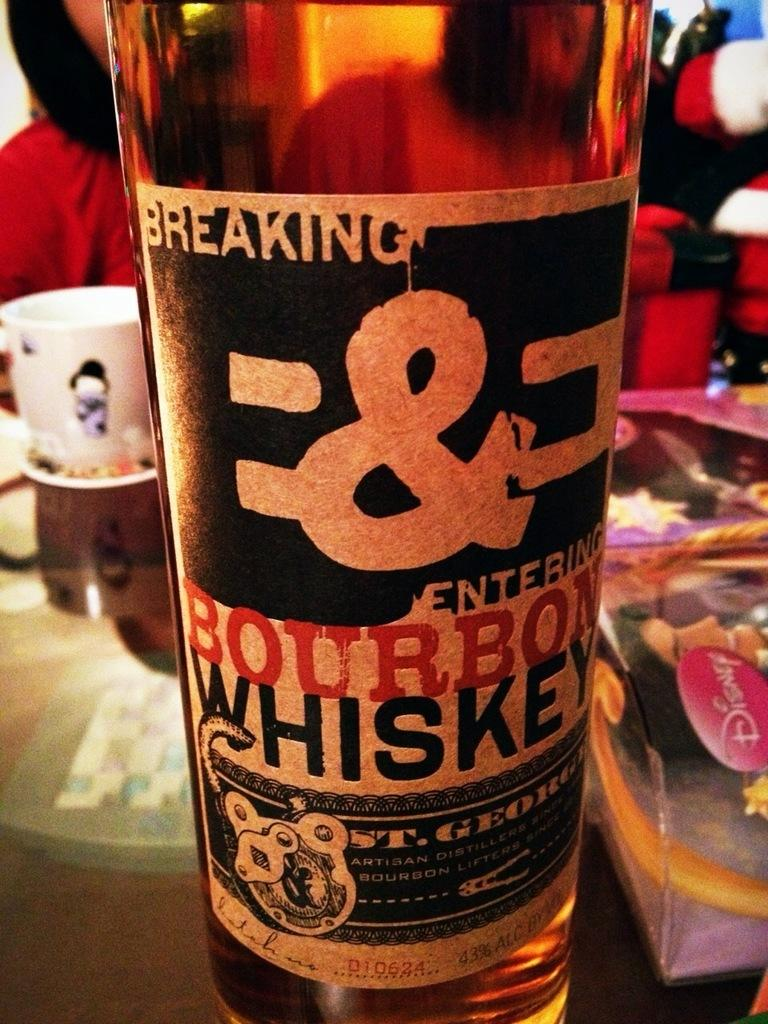<image>
Write a terse but informative summary of the picture. A bottle of Bourbon Whiskey called Breaking and Entering. 